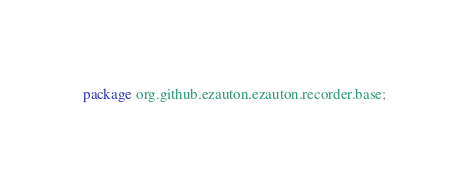<code> <loc_0><loc_0><loc_500><loc_500><_Java_>package org.github.ezauton.ezauton.recorder.base;
</code> 